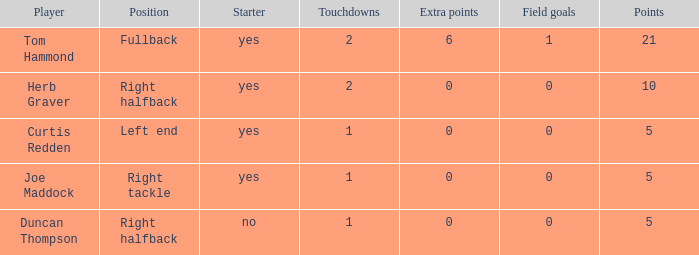Can you mention the lowest number of touchdowns? 1.0. Could you parse the entire table as a dict? {'header': ['Player', 'Position', 'Starter', 'Touchdowns', 'Extra points', 'Field goals', 'Points'], 'rows': [['Tom Hammond', 'Fullback', 'yes', '2', '6', '1', '21'], ['Herb Graver', 'Right halfback', 'yes', '2', '0', '0', '10'], ['Curtis Redden', 'Left end', 'yes', '1', '0', '0', '5'], ['Joe Maddock', 'Right tackle', 'yes', '1', '0', '0', '5'], ['Duncan Thompson', 'Right halfback', 'no', '1', '0', '0', '5']]} 